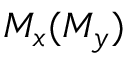<formula> <loc_0><loc_0><loc_500><loc_500>M _ { x } ( M _ { y } )</formula> 